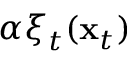Convert formula to latex. <formula><loc_0><loc_0><loc_500><loc_500>\alpha \xi _ { t } ( { x } _ { t } )</formula> 